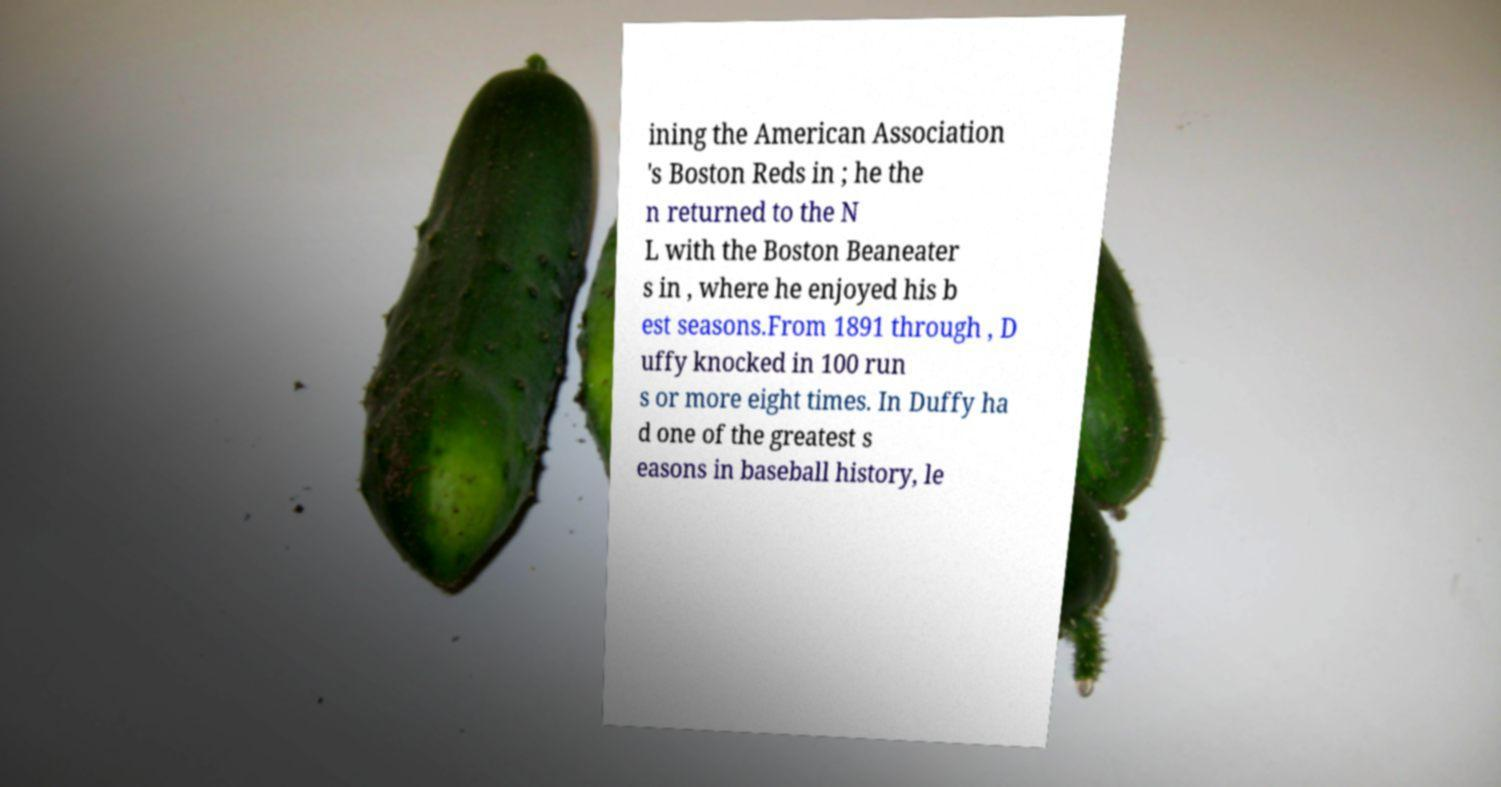Please read and relay the text visible in this image. What does it say? ining the American Association 's Boston Reds in ; he the n returned to the N L with the Boston Beaneater s in , where he enjoyed his b est seasons.From 1891 through , D uffy knocked in 100 run s or more eight times. In Duffy ha d one of the greatest s easons in baseball history, le 